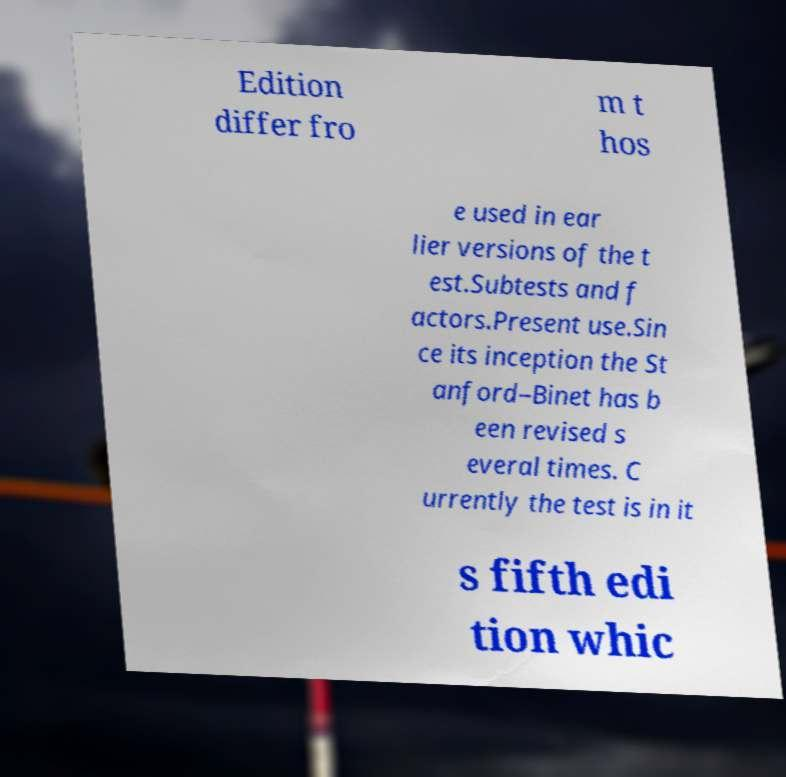I need the written content from this picture converted into text. Can you do that? Edition differ fro m t hos e used in ear lier versions of the t est.Subtests and f actors.Present use.Sin ce its inception the St anford–Binet has b een revised s everal times. C urrently the test is in it s fifth edi tion whic 